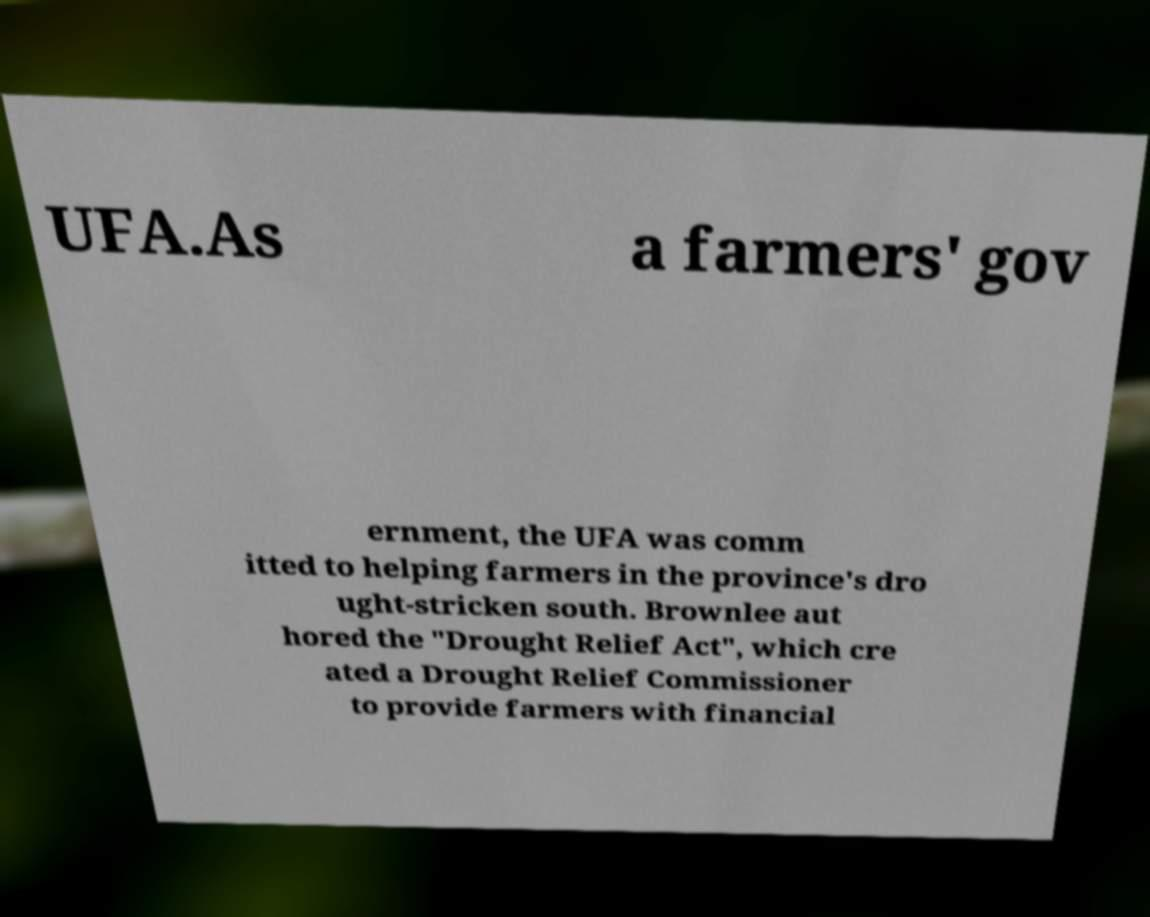What messages or text are displayed in this image? I need them in a readable, typed format. UFA.As a farmers' gov ernment, the UFA was comm itted to helping farmers in the province's dro ught-stricken south. Brownlee aut hored the "Drought Relief Act", which cre ated a Drought Relief Commissioner to provide farmers with financial 